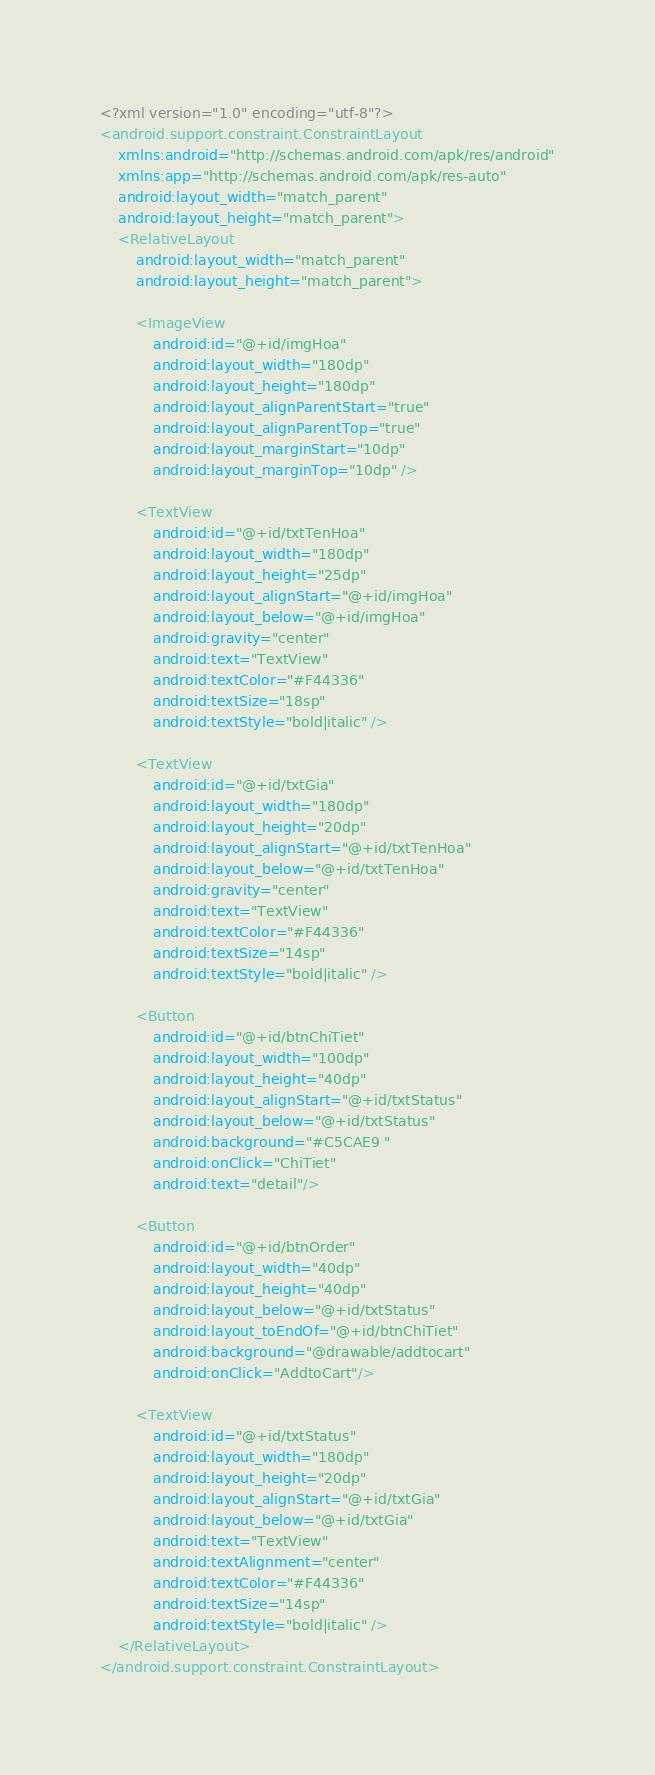Convert code to text. <code><loc_0><loc_0><loc_500><loc_500><_XML_><?xml version="1.0" encoding="utf-8"?>
<android.support.constraint.ConstraintLayout
    xmlns:android="http://schemas.android.com/apk/res/android"
    xmlns:app="http://schemas.android.com/apk/res-auto"
    android:layout_width="match_parent"
    android:layout_height="match_parent">
    <RelativeLayout
        android:layout_width="match_parent"
        android:layout_height="match_parent">

        <ImageView
            android:id="@+id/imgHoa"
            android:layout_width="180dp"
            android:layout_height="180dp"
            android:layout_alignParentStart="true"
            android:layout_alignParentTop="true"
            android:layout_marginStart="10dp"
            android:layout_marginTop="10dp" />

        <TextView
            android:id="@+id/txtTenHoa"
            android:layout_width="180dp"
            android:layout_height="25dp"
            android:layout_alignStart="@+id/imgHoa"
            android:layout_below="@+id/imgHoa"
            android:gravity="center"
            android:text="TextView"
            android:textColor="#F44336"
            android:textSize="18sp"
            android:textStyle="bold|italic" />

        <TextView
            android:id="@+id/txtGia"
            android:layout_width="180dp"
            android:layout_height="20dp"
            android:layout_alignStart="@+id/txtTenHoa"
            android:layout_below="@+id/txtTenHoa"
            android:gravity="center"
            android:text="TextView"
            android:textColor="#F44336"
            android:textSize="14sp"
            android:textStyle="bold|italic" />

        <Button
            android:id="@+id/btnChiTiet"
            android:layout_width="100dp"
            android:layout_height="40dp"
            android:layout_alignStart="@+id/txtStatus"
            android:layout_below="@+id/txtStatus"
            android:background="#C5CAE9 "
            android:onClick="ChiTiet"
            android:text="detail"/>

        <Button
            android:id="@+id/btnOrder"
            android:layout_width="40dp"
            android:layout_height="40dp"
            android:layout_below="@+id/txtStatus"
            android:layout_toEndOf="@+id/btnChiTiet"
            android:background="@drawable/addtocart"
            android:onClick="AddtoCart"/>

        <TextView
            android:id="@+id/txtStatus"
            android:layout_width="180dp"
            android:layout_height="20dp"
            android:layout_alignStart="@+id/txtGia"
            android:layout_below="@+id/txtGia"
            android:text="TextView"
            android:textAlignment="center"
            android:textColor="#F44336"
            android:textSize="14sp"
            android:textStyle="bold|italic" />
    </RelativeLayout>
</android.support.constraint.ConstraintLayout></code> 